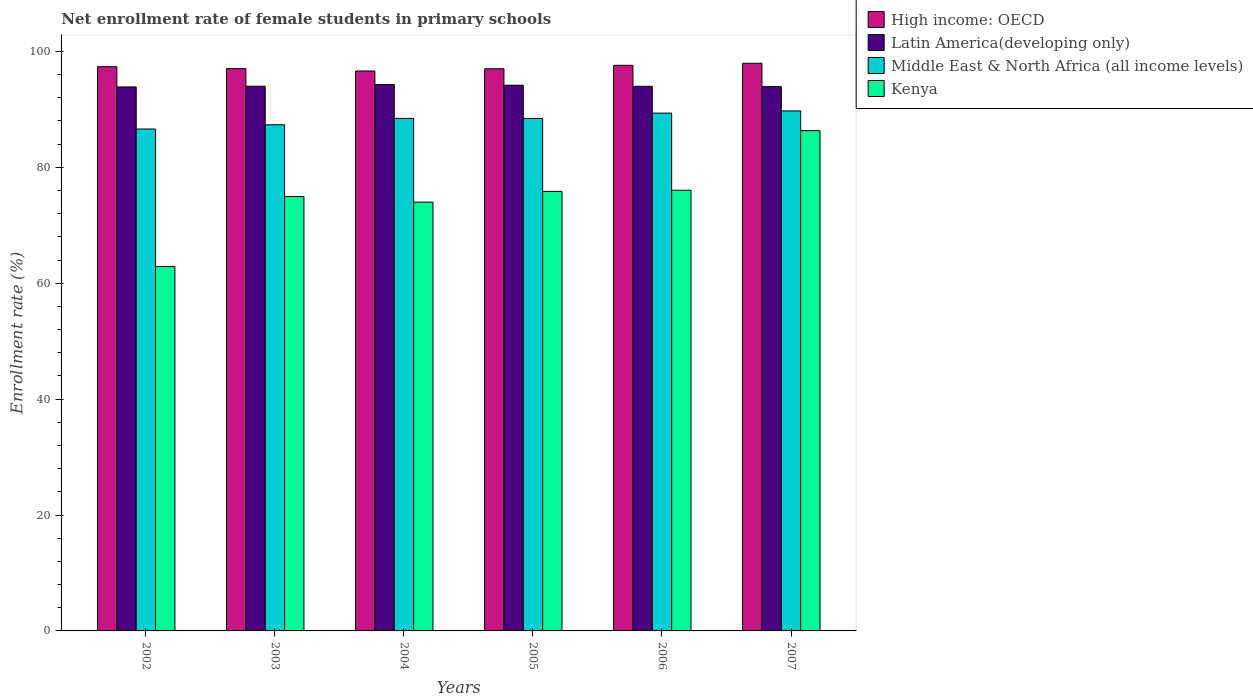How many groups of bars are there?
Make the answer very short. 6. Are the number of bars per tick equal to the number of legend labels?
Give a very brief answer. Yes. How many bars are there on the 2nd tick from the right?
Offer a terse response. 4. In how many cases, is the number of bars for a given year not equal to the number of legend labels?
Your response must be concise. 0. What is the net enrollment rate of female students in primary schools in High income: OECD in 2002?
Your answer should be compact. 97.37. Across all years, what is the maximum net enrollment rate of female students in primary schools in Latin America(developing only)?
Your answer should be very brief. 94.3. Across all years, what is the minimum net enrollment rate of female students in primary schools in Middle East & North Africa (all income levels)?
Keep it short and to the point. 86.61. In which year was the net enrollment rate of female students in primary schools in Kenya maximum?
Offer a very short reply. 2007. In which year was the net enrollment rate of female students in primary schools in Middle East & North Africa (all income levels) minimum?
Keep it short and to the point. 2002. What is the total net enrollment rate of female students in primary schools in Kenya in the graph?
Offer a terse response. 450.08. What is the difference between the net enrollment rate of female students in primary schools in Latin America(developing only) in 2004 and that in 2005?
Keep it short and to the point. 0.13. What is the difference between the net enrollment rate of female students in primary schools in High income: OECD in 2007 and the net enrollment rate of female students in primary schools in Middle East & North Africa (all income levels) in 2002?
Make the answer very short. 11.35. What is the average net enrollment rate of female students in primary schools in High income: OECD per year?
Offer a terse response. 97.27. In the year 2005, what is the difference between the net enrollment rate of female students in primary schools in Middle East & North Africa (all income levels) and net enrollment rate of female students in primary schools in High income: OECD?
Make the answer very short. -8.58. What is the ratio of the net enrollment rate of female students in primary schools in High income: OECD in 2002 to that in 2004?
Your response must be concise. 1.01. Is the net enrollment rate of female students in primary schools in High income: OECD in 2002 less than that in 2005?
Keep it short and to the point. No. Is the difference between the net enrollment rate of female students in primary schools in Middle East & North Africa (all income levels) in 2002 and 2005 greater than the difference between the net enrollment rate of female students in primary schools in High income: OECD in 2002 and 2005?
Provide a succinct answer. No. What is the difference between the highest and the second highest net enrollment rate of female students in primary schools in High income: OECD?
Provide a short and direct response. 0.35. What is the difference between the highest and the lowest net enrollment rate of female students in primary schools in Kenya?
Your answer should be very brief. 23.45. Is the sum of the net enrollment rate of female students in primary schools in Latin America(developing only) in 2005 and 2007 greater than the maximum net enrollment rate of female students in primary schools in Kenya across all years?
Provide a short and direct response. Yes. Is it the case that in every year, the sum of the net enrollment rate of female students in primary schools in Middle East & North Africa (all income levels) and net enrollment rate of female students in primary schools in Latin America(developing only) is greater than the sum of net enrollment rate of female students in primary schools in Kenya and net enrollment rate of female students in primary schools in High income: OECD?
Keep it short and to the point. No. What does the 2nd bar from the left in 2006 represents?
Your response must be concise. Latin America(developing only). What does the 3rd bar from the right in 2004 represents?
Offer a terse response. Latin America(developing only). Is it the case that in every year, the sum of the net enrollment rate of female students in primary schools in Latin America(developing only) and net enrollment rate of female students in primary schools in Middle East & North Africa (all income levels) is greater than the net enrollment rate of female students in primary schools in Kenya?
Provide a succinct answer. Yes. Are all the bars in the graph horizontal?
Provide a short and direct response. No. How many years are there in the graph?
Your answer should be very brief. 6. What is the difference between two consecutive major ticks on the Y-axis?
Give a very brief answer. 20. Are the values on the major ticks of Y-axis written in scientific E-notation?
Keep it short and to the point. No. Does the graph contain any zero values?
Your response must be concise. No. Does the graph contain grids?
Your answer should be very brief. No. Where does the legend appear in the graph?
Ensure brevity in your answer.  Top right. How many legend labels are there?
Give a very brief answer. 4. How are the legend labels stacked?
Offer a terse response. Vertical. What is the title of the graph?
Your answer should be compact. Net enrollment rate of female students in primary schools. Does "St. Kitts and Nevis" appear as one of the legend labels in the graph?
Offer a very short reply. No. What is the label or title of the X-axis?
Provide a short and direct response. Years. What is the label or title of the Y-axis?
Your answer should be compact. Enrollment rate (%). What is the Enrollment rate (%) in High income: OECD in 2002?
Offer a terse response. 97.37. What is the Enrollment rate (%) in Latin America(developing only) in 2002?
Provide a short and direct response. 93.88. What is the Enrollment rate (%) in Middle East & North Africa (all income levels) in 2002?
Provide a succinct answer. 86.61. What is the Enrollment rate (%) in Kenya in 2002?
Ensure brevity in your answer.  62.89. What is the Enrollment rate (%) in High income: OECD in 2003?
Ensure brevity in your answer.  97.03. What is the Enrollment rate (%) in Latin America(developing only) in 2003?
Provide a short and direct response. 94. What is the Enrollment rate (%) of Middle East & North Africa (all income levels) in 2003?
Your response must be concise. 87.35. What is the Enrollment rate (%) in Kenya in 2003?
Ensure brevity in your answer.  74.96. What is the Enrollment rate (%) in High income: OECD in 2004?
Give a very brief answer. 96.63. What is the Enrollment rate (%) in Latin America(developing only) in 2004?
Provide a short and direct response. 94.3. What is the Enrollment rate (%) in Middle East & North Africa (all income levels) in 2004?
Provide a succinct answer. 88.44. What is the Enrollment rate (%) in Kenya in 2004?
Provide a short and direct response. 73.99. What is the Enrollment rate (%) in High income: OECD in 2005?
Make the answer very short. 97.01. What is the Enrollment rate (%) of Latin America(developing only) in 2005?
Make the answer very short. 94.17. What is the Enrollment rate (%) of Middle East & North Africa (all income levels) in 2005?
Your answer should be very brief. 88.43. What is the Enrollment rate (%) in Kenya in 2005?
Provide a succinct answer. 75.85. What is the Enrollment rate (%) in High income: OECD in 2006?
Offer a very short reply. 97.61. What is the Enrollment rate (%) in Latin America(developing only) in 2006?
Make the answer very short. 93.98. What is the Enrollment rate (%) in Middle East & North Africa (all income levels) in 2006?
Your answer should be compact. 89.35. What is the Enrollment rate (%) of Kenya in 2006?
Make the answer very short. 76.05. What is the Enrollment rate (%) of High income: OECD in 2007?
Your answer should be very brief. 97.96. What is the Enrollment rate (%) in Latin America(developing only) in 2007?
Provide a succinct answer. 93.93. What is the Enrollment rate (%) of Middle East & North Africa (all income levels) in 2007?
Ensure brevity in your answer.  89.74. What is the Enrollment rate (%) in Kenya in 2007?
Keep it short and to the point. 86.34. Across all years, what is the maximum Enrollment rate (%) of High income: OECD?
Your answer should be compact. 97.96. Across all years, what is the maximum Enrollment rate (%) of Latin America(developing only)?
Your response must be concise. 94.3. Across all years, what is the maximum Enrollment rate (%) of Middle East & North Africa (all income levels)?
Make the answer very short. 89.74. Across all years, what is the maximum Enrollment rate (%) of Kenya?
Your answer should be very brief. 86.34. Across all years, what is the minimum Enrollment rate (%) of High income: OECD?
Provide a succinct answer. 96.63. Across all years, what is the minimum Enrollment rate (%) in Latin America(developing only)?
Provide a short and direct response. 93.88. Across all years, what is the minimum Enrollment rate (%) in Middle East & North Africa (all income levels)?
Your answer should be very brief. 86.61. Across all years, what is the minimum Enrollment rate (%) of Kenya?
Provide a succinct answer. 62.89. What is the total Enrollment rate (%) of High income: OECD in the graph?
Provide a short and direct response. 583.6. What is the total Enrollment rate (%) of Latin America(developing only) in the graph?
Make the answer very short. 564.26. What is the total Enrollment rate (%) in Middle East & North Africa (all income levels) in the graph?
Ensure brevity in your answer.  529.92. What is the total Enrollment rate (%) of Kenya in the graph?
Your response must be concise. 450.08. What is the difference between the Enrollment rate (%) in High income: OECD in 2002 and that in 2003?
Your answer should be very brief. 0.34. What is the difference between the Enrollment rate (%) in Latin America(developing only) in 2002 and that in 2003?
Give a very brief answer. -0.12. What is the difference between the Enrollment rate (%) of Middle East & North Africa (all income levels) in 2002 and that in 2003?
Provide a short and direct response. -0.74. What is the difference between the Enrollment rate (%) in Kenya in 2002 and that in 2003?
Make the answer very short. -12.07. What is the difference between the Enrollment rate (%) in High income: OECD in 2002 and that in 2004?
Offer a terse response. 0.74. What is the difference between the Enrollment rate (%) of Latin America(developing only) in 2002 and that in 2004?
Give a very brief answer. -0.42. What is the difference between the Enrollment rate (%) of Middle East & North Africa (all income levels) in 2002 and that in 2004?
Offer a terse response. -1.84. What is the difference between the Enrollment rate (%) of Kenya in 2002 and that in 2004?
Ensure brevity in your answer.  -11.1. What is the difference between the Enrollment rate (%) in High income: OECD in 2002 and that in 2005?
Keep it short and to the point. 0.36. What is the difference between the Enrollment rate (%) of Latin America(developing only) in 2002 and that in 2005?
Your response must be concise. -0.29. What is the difference between the Enrollment rate (%) in Middle East & North Africa (all income levels) in 2002 and that in 2005?
Offer a terse response. -1.82. What is the difference between the Enrollment rate (%) of Kenya in 2002 and that in 2005?
Ensure brevity in your answer.  -12.95. What is the difference between the Enrollment rate (%) of High income: OECD in 2002 and that in 2006?
Keep it short and to the point. -0.24. What is the difference between the Enrollment rate (%) in Latin America(developing only) in 2002 and that in 2006?
Keep it short and to the point. -0.1. What is the difference between the Enrollment rate (%) in Middle East & North Africa (all income levels) in 2002 and that in 2006?
Offer a terse response. -2.74. What is the difference between the Enrollment rate (%) in Kenya in 2002 and that in 2006?
Your answer should be compact. -13.16. What is the difference between the Enrollment rate (%) of High income: OECD in 2002 and that in 2007?
Keep it short and to the point. -0.59. What is the difference between the Enrollment rate (%) in Latin America(developing only) in 2002 and that in 2007?
Provide a succinct answer. -0.05. What is the difference between the Enrollment rate (%) in Middle East & North Africa (all income levels) in 2002 and that in 2007?
Provide a short and direct response. -3.13. What is the difference between the Enrollment rate (%) of Kenya in 2002 and that in 2007?
Offer a terse response. -23.45. What is the difference between the Enrollment rate (%) in High income: OECD in 2003 and that in 2004?
Make the answer very short. 0.4. What is the difference between the Enrollment rate (%) in Latin America(developing only) in 2003 and that in 2004?
Offer a terse response. -0.3. What is the difference between the Enrollment rate (%) in Middle East & North Africa (all income levels) in 2003 and that in 2004?
Provide a short and direct response. -1.1. What is the difference between the Enrollment rate (%) in Kenya in 2003 and that in 2004?
Provide a succinct answer. 0.97. What is the difference between the Enrollment rate (%) in High income: OECD in 2003 and that in 2005?
Make the answer very short. 0.02. What is the difference between the Enrollment rate (%) of Latin America(developing only) in 2003 and that in 2005?
Your answer should be very brief. -0.17. What is the difference between the Enrollment rate (%) of Middle East & North Africa (all income levels) in 2003 and that in 2005?
Your answer should be very brief. -1.08. What is the difference between the Enrollment rate (%) of Kenya in 2003 and that in 2005?
Your answer should be very brief. -0.89. What is the difference between the Enrollment rate (%) in High income: OECD in 2003 and that in 2006?
Offer a very short reply. -0.58. What is the difference between the Enrollment rate (%) in Latin America(developing only) in 2003 and that in 2006?
Keep it short and to the point. 0.02. What is the difference between the Enrollment rate (%) in Middle East & North Africa (all income levels) in 2003 and that in 2006?
Provide a short and direct response. -2.01. What is the difference between the Enrollment rate (%) in Kenya in 2003 and that in 2006?
Your response must be concise. -1.09. What is the difference between the Enrollment rate (%) of High income: OECD in 2003 and that in 2007?
Give a very brief answer. -0.93. What is the difference between the Enrollment rate (%) of Latin America(developing only) in 2003 and that in 2007?
Give a very brief answer. 0.07. What is the difference between the Enrollment rate (%) in Middle East & North Africa (all income levels) in 2003 and that in 2007?
Provide a short and direct response. -2.39. What is the difference between the Enrollment rate (%) of Kenya in 2003 and that in 2007?
Your answer should be very brief. -11.38. What is the difference between the Enrollment rate (%) in High income: OECD in 2004 and that in 2005?
Give a very brief answer. -0.38. What is the difference between the Enrollment rate (%) in Latin America(developing only) in 2004 and that in 2005?
Provide a succinct answer. 0.13. What is the difference between the Enrollment rate (%) of Middle East & North Africa (all income levels) in 2004 and that in 2005?
Ensure brevity in your answer.  0.01. What is the difference between the Enrollment rate (%) of Kenya in 2004 and that in 2005?
Provide a succinct answer. -1.85. What is the difference between the Enrollment rate (%) in High income: OECD in 2004 and that in 2006?
Your response must be concise. -0.98. What is the difference between the Enrollment rate (%) of Latin America(developing only) in 2004 and that in 2006?
Ensure brevity in your answer.  0.32. What is the difference between the Enrollment rate (%) of Middle East & North Africa (all income levels) in 2004 and that in 2006?
Your response must be concise. -0.91. What is the difference between the Enrollment rate (%) of Kenya in 2004 and that in 2006?
Give a very brief answer. -2.06. What is the difference between the Enrollment rate (%) in High income: OECD in 2004 and that in 2007?
Your response must be concise. -1.33. What is the difference between the Enrollment rate (%) of Latin America(developing only) in 2004 and that in 2007?
Your response must be concise. 0.37. What is the difference between the Enrollment rate (%) in Middle East & North Africa (all income levels) in 2004 and that in 2007?
Offer a very short reply. -1.29. What is the difference between the Enrollment rate (%) of Kenya in 2004 and that in 2007?
Ensure brevity in your answer.  -12.35. What is the difference between the Enrollment rate (%) in High income: OECD in 2005 and that in 2006?
Your answer should be compact. -0.6. What is the difference between the Enrollment rate (%) of Latin America(developing only) in 2005 and that in 2006?
Give a very brief answer. 0.19. What is the difference between the Enrollment rate (%) of Middle East & North Africa (all income levels) in 2005 and that in 2006?
Keep it short and to the point. -0.92. What is the difference between the Enrollment rate (%) of Kenya in 2005 and that in 2006?
Keep it short and to the point. -0.21. What is the difference between the Enrollment rate (%) in High income: OECD in 2005 and that in 2007?
Your answer should be very brief. -0.95. What is the difference between the Enrollment rate (%) in Latin America(developing only) in 2005 and that in 2007?
Provide a short and direct response. 0.24. What is the difference between the Enrollment rate (%) of Middle East & North Africa (all income levels) in 2005 and that in 2007?
Your answer should be compact. -1.31. What is the difference between the Enrollment rate (%) in Kenya in 2005 and that in 2007?
Your answer should be compact. -10.49. What is the difference between the Enrollment rate (%) in High income: OECD in 2006 and that in 2007?
Your answer should be compact. -0.35. What is the difference between the Enrollment rate (%) of Latin America(developing only) in 2006 and that in 2007?
Keep it short and to the point. 0.05. What is the difference between the Enrollment rate (%) of Middle East & North Africa (all income levels) in 2006 and that in 2007?
Give a very brief answer. -0.38. What is the difference between the Enrollment rate (%) of Kenya in 2006 and that in 2007?
Provide a short and direct response. -10.29. What is the difference between the Enrollment rate (%) of High income: OECD in 2002 and the Enrollment rate (%) of Latin America(developing only) in 2003?
Offer a very short reply. 3.37. What is the difference between the Enrollment rate (%) of High income: OECD in 2002 and the Enrollment rate (%) of Middle East & North Africa (all income levels) in 2003?
Give a very brief answer. 10.02. What is the difference between the Enrollment rate (%) in High income: OECD in 2002 and the Enrollment rate (%) in Kenya in 2003?
Your response must be concise. 22.41. What is the difference between the Enrollment rate (%) in Latin America(developing only) in 2002 and the Enrollment rate (%) in Middle East & North Africa (all income levels) in 2003?
Ensure brevity in your answer.  6.53. What is the difference between the Enrollment rate (%) of Latin America(developing only) in 2002 and the Enrollment rate (%) of Kenya in 2003?
Provide a short and direct response. 18.92. What is the difference between the Enrollment rate (%) of Middle East & North Africa (all income levels) in 2002 and the Enrollment rate (%) of Kenya in 2003?
Give a very brief answer. 11.65. What is the difference between the Enrollment rate (%) in High income: OECD in 2002 and the Enrollment rate (%) in Latin America(developing only) in 2004?
Your answer should be very brief. 3.07. What is the difference between the Enrollment rate (%) in High income: OECD in 2002 and the Enrollment rate (%) in Middle East & North Africa (all income levels) in 2004?
Offer a terse response. 8.92. What is the difference between the Enrollment rate (%) in High income: OECD in 2002 and the Enrollment rate (%) in Kenya in 2004?
Keep it short and to the point. 23.38. What is the difference between the Enrollment rate (%) in Latin America(developing only) in 2002 and the Enrollment rate (%) in Middle East & North Africa (all income levels) in 2004?
Provide a short and direct response. 5.43. What is the difference between the Enrollment rate (%) of Latin America(developing only) in 2002 and the Enrollment rate (%) of Kenya in 2004?
Give a very brief answer. 19.89. What is the difference between the Enrollment rate (%) in Middle East & North Africa (all income levels) in 2002 and the Enrollment rate (%) in Kenya in 2004?
Your answer should be very brief. 12.62. What is the difference between the Enrollment rate (%) in High income: OECD in 2002 and the Enrollment rate (%) in Latin America(developing only) in 2005?
Your answer should be compact. 3.2. What is the difference between the Enrollment rate (%) of High income: OECD in 2002 and the Enrollment rate (%) of Middle East & North Africa (all income levels) in 2005?
Ensure brevity in your answer.  8.94. What is the difference between the Enrollment rate (%) of High income: OECD in 2002 and the Enrollment rate (%) of Kenya in 2005?
Keep it short and to the point. 21.52. What is the difference between the Enrollment rate (%) in Latin America(developing only) in 2002 and the Enrollment rate (%) in Middle East & North Africa (all income levels) in 2005?
Your response must be concise. 5.45. What is the difference between the Enrollment rate (%) in Latin America(developing only) in 2002 and the Enrollment rate (%) in Kenya in 2005?
Offer a terse response. 18.03. What is the difference between the Enrollment rate (%) in Middle East & North Africa (all income levels) in 2002 and the Enrollment rate (%) in Kenya in 2005?
Make the answer very short. 10.76. What is the difference between the Enrollment rate (%) of High income: OECD in 2002 and the Enrollment rate (%) of Latin America(developing only) in 2006?
Make the answer very short. 3.39. What is the difference between the Enrollment rate (%) of High income: OECD in 2002 and the Enrollment rate (%) of Middle East & North Africa (all income levels) in 2006?
Give a very brief answer. 8.02. What is the difference between the Enrollment rate (%) of High income: OECD in 2002 and the Enrollment rate (%) of Kenya in 2006?
Offer a very short reply. 21.32. What is the difference between the Enrollment rate (%) in Latin America(developing only) in 2002 and the Enrollment rate (%) in Middle East & North Africa (all income levels) in 2006?
Provide a succinct answer. 4.52. What is the difference between the Enrollment rate (%) in Latin America(developing only) in 2002 and the Enrollment rate (%) in Kenya in 2006?
Your answer should be very brief. 17.82. What is the difference between the Enrollment rate (%) in Middle East & North Africa (all income levels) in 2002 and the Enrollment rate (%) in Kenya in 2006?
Provide a succinct answer. 10.56. What is the difference between the Enrollment rate (%) in High income: OECD in 2002 and the Enrollment rate (%) in Latin America(developing only) in 2007?
Your answer should be very brief. 3.44. What is the difference between the Enrollment rate (%) in High income: OECD in 2002 and the Enrollment rate (%) in Middle East & North Africa (all income levels) in 2007?
Offer a very short reply. 7.63. What is the difference between the Enrollment rate (%) of High income: OECD in 2002 and the Enrollment rate (%) of Kenya in 2007?
Provide a succinct answer. 11.03. What is the difference between the Enrollment rate (%) of Latin America(developing only) in 2002 and the Enrollment rate (%) of Middle East & North Africa (all income levels) in 2007?
Your response must be concise. 4.14. What is the difference between the Enrollment rate (%) of Latin America(developing only) in 2002 and the Enrollment rate (%) of Kenya in 2007?
Make the answer very short. 7.54. What is the difference between the Enrollment rate (%) of Middle East & North Africa (all income levels) in 2002 and the Enrollment rate (%) of Kenya in 2007?
Provide a succinct answer. 0.27. What is the difference between the Enrollment rate (%) of High income: OECD in 2003 and the Enrollment rate (%) of Latin America(developing only) in 2004?
Your response must be concise. 2.73. What is the difference between the Enrollment rate (%) in High income: OECD in 2003 and the Enrollment rate (%) in Middle East & North Africa (all income levels) in 2004?
Your response must be concise. 8.58. What is the difference between the Enrollment rate (%) of High income: OECD in 2003 and the Enrollment rate (%) of Kenya in 2004?
Give a very brief answer. 23.04. What is the difference between the Enrollment rate (%) of Latin America(developing only) in 2003 and the Enrollment rate (%) of Middle East & North Africa (all income levels) in 2004?
Keep it short and to the point. 5.55. What is the difference between the Enrollment rate (%) in Latin America(developing only) in 2003 and the Enrollment rate (%) in Kenya in 2004?
Your response must be concise. 20.01. What is the difference between the Enrollment rate (%) of Middle East & North Africa (all income levels) in 2003 and the Enrollment rate (%) of Kenya in 2004?
Ensure brevity in your answer.  13.36. What is the difference between the Enrollment rate (%) of High income: OECD in 2003 and the Enrollment rate (%) of Latin America(developing only) in 2005?
Your response must be concise. 2.86. What is the difference between the Enrollment rate (%) in High income: OECD in 2003 and the Enrollment rate (%) in Middle East & North Africa (all income levels) in 2005?
Keep it short and to the point. 8.6. What is the difference between the Enrollment rate (%) of High income: OECD in 2003 and the Enrollment rate (%) of Kenya in 2005?
Offer a terse response. 21.18. What is the difference between the Enrollment rate (%) in Latin America(developing only) in 2003 and the Enrollment rate (%) in Middle East & North Africa (all income levels) in 2005?
Offer a terse response. 5.57. What is the difference between the Enrollment rate (%) in Latin America(developing only) in 2003 and the Enrollment rate (%) in Kenya in 2005?
Provide a succinct answer. 18.15. What is the difference between the Enrollment rate (%) of Middle East & North Africa (all income levels) in 2003 and the Enrollment rate (%) of Kenya in 2005?
Provide a succinct answer. 11.5. What is the difference between the Enrollment rate (%) of High income: OECD in 2003 and the Enrollment rate (%) of Latin America(developing only) in 2006?
Make the answer very short. 3.05. What is the difference between the Enrollment rate (%) in High income: OECD in 2003 and the Enrollment rate (%) in Middle East & North Africa (all income levels) in 2006?
Keep it short and to the point. 7.68. What is the difference between the Enrollment rate (%) of High income: OECD in 2003 and the Enrollment rate (%) of Kenya in 2006?
Ensure brevity in your answer.  20.98. What is the difference between the Enrollment rate (%) in Latin America(developing only) in 2003 and the Enrollment rate (%) in Middle East & North Africa (all income levels) in 2006?
Offer a terse response. 4.65. What is the difference between the Enrollment rate (%) in Latin America(developing only) in 2003 and the Enrollment rate (%) in Kenya in 2006?
Offer a terse response. 17.95. What is the difference between the Enrollment rate (%) in Middle East & North Africa (all income levels) in 2003 and the Enrollment rate (%) in Kenya in 2006?
Give a very brief answer. 11.29. What is the difference between the Enrollment rate (%) of High income: OECD in 2003 and the Enrollment rate (%) of Latin America(developing only) in 2007?
Your response must be concise. 3.1. What is the difference between the Enrollment rate (%) in High income: OECD in 2003 and the Enrollment rate (%) in Middle East & North Africa (all income levels) in 2007?
Keep it short and to the point. 7.29. What is the difference between the Enrollment rate (%) in High income: OECD in 2003 and the Enrollment rate (%) in Kenya in 2007?
Provide a short and direct response. 10.69. What is the difference between the Enrollment rate (%) of Latin America(developing only) in 2003 and the Enrollment rate (%) of Middle East & North Africa (all income levels) in 2007?
Make the answer very short. 4.26. What is the difference between the Enrollment rate (%) in Latin America(developing only) in 2003 and the Enrollment rate (%) in Kenya in 2007?
Make the answer very short. 7.66. What is the difference between the Enrollment rate (%) in High income: OECD in 2004 and the Enrollment rate (%) in Latin America(developing only) in 2005?
Ensure brevity in your answer.  2.46. What is the difference between the Enrollment rate (%) in High income: OECD in 2004 and the Enrollment rate (%) in Middle East & North Africa (all income levels) in 2005?
Ensure brevity in your answer.  8.2. What is the difference between the Enrollment rate (%) of High income: OECD in 2004 and the Enrollment rate (%) of Kenya in 2005?
Offer a terse response. 20.78. What is the difference between the Enrollment rate (%) in Latin America(developing only) in 2004 and the Enrollment rate (%) in Middle East & North Africa (all income levels) in 2005?
Keep it short and to the point. 5.87. What is the difference between the Enrollment rate (%) in Latin America(developing only) in 2004 and the Enrollment rate (%) in Kenya in 2005?
Your response must be concise. 18.45. What is the difference between the Enrollment rate (%) in Middle East & North Africa (all income levels) in 2004 and the Enrollment rate (%) in Kenya in 2005?
Make the answer very short. 12.6. What is the difference between the Enrollment rate (%) of High income: OECD in 2004 and the Enrollment rate (%) of Latin America(developing only) in 2006?
Your answer should be compact. 2.65. What is the difference between the Enrollment rate (%) in High income: OECD in 2004 and the Enrollment rate (%) in Middle East & North Africa (all income levels) in 2006?
Provide a succinct answer. 7.27. What is the difference between the Enrollment rate (%) in High income: OECD in 2004 and the Enrollment rate (%) in Kenya in 2006?
Offer a very short reply. 20.57. What is the difference between the Enrollment rate (%) in Latin America(developing only) in 2004 and the Enrollment rate (%) in Middle East & North Africa (all income levels) in 2006?
Give a very brief answer. 4.94. What is the difference between the Enrollment rate (%) of Latin America(developing only) in 2004 and the Enrollment rate (%) of Kenya in 2006?
Keep it short and to the point. 18.25. What is the difference between the Enrollment rate (%) in Middle East & North Africa (all income levels) in 2004 and the Enrollment rate (%) in Kenya in 2006?
Give a very brief answer. 12.39. What is the difference between the Enrollment rate (%) in High income: OECD in 2004 and the Enrollment rate (%) in Latin America(developing only) in 2007?
Provide a succinct answer. 2.7. What is the difference between the Enrollment rate (%) of High income: OECD in 2004 and the Enrollment rate (%) of Middle East & North Africa (all income levels) in 2007?
Your answer should be very brief. 6.89. What is the difference between the Enrollment rate (%) of High income: OECD in 2004 and the Enrollment rate (%) of Kenya in 2007?
Ensure brevity in your answer.  10.29. What is the difference between the Enrollment rate (%) in Latin America(developing only) in 2004 and the Enrollment rate (%) in Middle East & North Africa (all income levels) in 2007?
Provide a short and direct response. 4.56. What is the difference between the Enrollment rate (%) in Latin America(developing only) in 2004 and the Enrollment rate (%) in Kenya in 2007?
Ensure brevity in your answer.  7.96. What is the difference between the Enrollment rate (%) in Middle East & North Africa (all income levels) in 2004 and the Enrollment rate (%) in Kenya in 2007?
Provide a succinct answer. 2.11. What is the difference between the Enrollment rate (%) of High income: OECD in 2005 and the Enrollment rate (%) of Latin America(developing only) in 2006?
Provide a succinct answer. 3.03. What is the difference between the Enrollment rate (%) in High income: OECD in 2005 and the Enrollment rate (%) in Middle East & North Africa (all income levels) in 2006?
Provide a short and direct response. 7.66. What is the difference between the Enrollment rate (%) of High income: OECD in 2005 and the Enrollment rate (%) of Kenya in 2006?
Keep it short and to the point. 20.96. What is the difference between the Enrollment rate (%) in Latin America(developing only) in 2005 and the Enrollment rate (%) in Middle East & North Africa (all income levels) in 2006?
Offer a terse response. 4.81. What is the difference between the Enrollment rate (%) of Latin America(developing only) in 2005 and the Enrollment rate (%) of Kenya in 2006?
Keep it short and to the point. 18.12. What is the difference between the Enrollment rate (%) in Middle East & North Africa (all income levels) in 2005 and the Enrollment rate (%) in Kenya in 2006?
Your answer should be compact. 12.38. What is the difference between the Enrollment rate (%) of High income: OECD in 2005 and the Enrollment rate (%) of Latin America(developing only) in 2007?
Give a very brief answer. 3.08. What is the difference between the Enrollment rate (%) in High income: OECD in 2005 and the Enrollment rate (%) in Middle East & North Africa (all income levels) in 2007?
Offer a very short reply. 7.28. What is the difference between the Enrollment rate (%) in High income: OECD in 2005 and the Enrollment rate (%) in Kenya in 2007?
Your answer should be compact. 10.67. What is the difference between the Enrollment rate (%) of Latin America(developing only) in 2005 and the Enrollment rate (%) of Middle East & North Africa (all income levels) in 2007?
Provide a short and direct response. 4.43. What is the difference between the Enrollment rate (%) of Latin America(developing only) in 2005 and the Enrollment rate (%) of Kenya in 2007?
Your answer should be compact. 7.83. What is the difference between the Enrollment rate (%) in Middle East & North Africa (all income levels) in 2005 and the Enrollment rate (%) in Kenya in 2007?
Give a very brief answer. 2.09. What is the difference between the Enrollment rate (%) of High income: OECD in 2006 and the Enrollment rate (%) of Latin America(developing only) in 2007?
Your answer should be compact. 3.68. What is the difference between the Enrollment rate (%) of High income: OECD in 2006 and the Enrollment rate (%) of Middle East & North Africa (all income levels) in 2007?
Your response must be concise. 7.87. What is the difference between the Enrollment rate (%) in High income: OECD in 2006 and the Enrollment rate (%) in Kenya in 2007?
Provide a succinct answer. 11.27. What is the difference between the Enrollment rate (%) in Latin America(developing only) in 2006 and the Enrollment rate (%) in Middle East & North Africa (all income levels) in 2007?
Make the answer very short. 4.25. What is the difference between the Enrollment rate (%) of Latin America(developing only) in 2006 and the Enrollment rate (%) of Kenya in 2007?
Your response must be concise. 7.64. What is the difference between the Enrollment rate (%) of Middle East & North Africa (all income levels) in 2006 and the Enrollment rate (%) of Kenya in 2007?
Offer a terse response. 3.01. What is the average Enrollment rate (%) in High income: OECD per year?
Offer a very short reply. 97.27. What is the average Enrollment rate (%) in Latin America(developing only) per year?
Ensure brevity in your answer.  94.04. What is the average Enrollment rate (%) of Middle East & North Africa (all income levels) per year?
Provide a short and direct response. 88.32. What is the average Enrollment rate (%) of Kenya per year?
Offer a terse response. 75.01. In the year 2002, what is the difference between the Enrollment rate (%) in High income: OECD and Enrollment rate (%) in Latin America(developing only)?
Your response must be concise. 3.49. In the year 2002, what is the difference between the Enrollment rate (%) of High income: OECD and Enrollment rate (%) of Middle East & North Africa (all income levels)?
Provide a short and direct response. 10.76. In the year 2002, what is the difference between the Enrollment rate (%) in High income: OECD and Enrollment rate (%) in Kenya?
Ensure brevity in your answer.  34.48. In the year 2002, what is the difference between the Enrollment rate (%) of Latin America(developing only) and Enrollment rate (%) of Middle East & North Africa (all income levels)?
Offer a terse response. 7.27. In the year 2002, what is the difference between the Enrollment rate (%) of Latin America(developing only) and Enrollment rate (%) of Kenya?
Your answer should be compact. 30.98. In the year 2002, what is the difference between the Enrollment rate (%) of Middle East & North Africa (all income levels) and Enrollment rate (%) of Kenya?
Provide a short and direct response. 23.72. In the year 2003, what is the difference between the Enrollment rate (%) of High income: OECD and Enrollment rate (%) of Latin America(developing only)?
Offer a terse response. 3.03. In the year 2003, what is the difference between the Enrollment rate (%) in High income: OECD and Enrollment rate (%) in Middle East & North Africa (all income levels)?
Your response must be concise. 9.68. In the year 2003, what is the difference between the Enrollment rate (%) of High income: OECD and Enrollment rate (%) of Kenya?
Provide a succinct answer. 22.07. In the year 2003, what is the difference between the Enrollment rate (%) in Latin America(developing only) and Enrollment rate (%) in Middle East & North Africa (all income levels)?
Provide a short and direct response. 6.65. In the year 2003, what is the difference between the Enrollment rate (%) in Latin America(developing only) and Enrollment rate (%) in Kenya?
Ensure brevity in your answer.  19.04. In the year 2003, what is the difference between the Enrollment rate (%) of Middle East & North Africa (all income levels) and Enrollment rate (%) of Kenya?
Ensure brevity in your answer.  12.39. In the year 2004, what is the difference between the Enrollment rate (%) of High income: OECD and Enrollment rate (%) of Latin America(developing only)?
Ensure brevity in your answer.  2.33. In the year 2004, what is the difference between the Enrollment rate (%) of High income: OECD and Enrollment rate (%) of Middle East & North Africa (all income levels)?
Provide a succinct answer. 8.18. In the year 2004, what is the difference between the Enrollment rate (%) in High income: OECD and Enrollment rate (%) in Kenya?
Keep it short and to the point. 22.64. In the year 2004, what is the difference between the Enrollment rate (%) in Latin America(developing only) and Enrollment rate (%) in Middle East & North Africa (all income levels)?
Ensure brevity in your answer.  5.85. In the year 2004, what is the difference between the Enrollment rate (%) in Latin America(developing only) and Enrollment rate (%) in Kenya?
Make the answer very short. 20.31. In the year 2004, what is the difference between the Enrollment rate (%) in Middle East & North Africa (all income levels) and Enrollment rate (%) in Kenya?
Your response must be concise. 14.45. In the year 2005, what is the difference between the Enrollment rate (%) of High income: OECD and Enrollment rate (%) of Latin America(developing only)?
Provide a short and direct response. 2.84. In the year 2005, what is the difference between the Enrollment rate (%) of High income: OECD and Enrollment rate (%) of Middle East & North Africa (all income levels)?
Your answer should be compact. 8.58. In the year 2005, what is the difference between the Enrollment rate (%) in High income: OECD and Enrollment rate (%) in Kenya?
Offer a terse response. 21.16. In the year 2005, what is the difference between the Enrollment rate (%) in Latin America(developing only) and Enrollment rate (%) in Middle East & North Africa (all income levels)?
Provide a succinct answer. 5.74. In the year 2005, what is the difference between the Enrollment rate (%) in Latin America(developing only) and Enrollment rate (%) in Kenya?
Give a very brief answer. 18.32. In the year 2005, what is the difference between the Enrollment rate (%) in Middle East & North Africa (all income levels) and Enrollment rate (%) in Kenya?
Your answer should be compact. 12.58. In the year 2006, what is the difference between the Enrollment rate (%) in High income: OECD and Enrollment rate (%) in Latin America(developing only)?
Make the answer very short. 3.63. In the year 2006, what is the difference between the Enrollment rate (%) of High income: OECD and Enrollment rate (%) of Middle East & North Africa (all income levels)?
Your response must be concise. 8.25. In the year 2006, what is the difference between the Enrollment rate (%) of High income: OECD and Enrollment rate (%) of Kenya?
Provide a succinct answer. 21.55. In the year 2006, what is the difference between the Enrollment rate (%) of Latin America(developing only) and Enrollment rate (%) of Middle East & North Africa (all income levels)?
Your response must be concise. 4.63. In the year 2006, what is the difference between the Enrollment rate (%) of Latin America(developing only) and Enrollment rate (%) of Kenya?
Keep it short and to the point. 17.93. In the year 2006, what is the difference between the Enrollment rate (%) of Middle East & North Africa (all income levels) and Enrollment rate (%) of Kenya?
Your answer should be compact. 13.3. In the year 2007, what is the difference between the Enrollment rate (%) in High income: OECD and Enrollment rate (%) in Latin America(developing only)?
Give a very brief answer. 4.03. In the year 2007, what is the difference between the Enrollment rate (%) of High income: OECD and Enrollment rate (%) of Middle East & North Africa (all income levels)?
Offer a terse response. 8.22. In the year 2007, what is the difference between the Enrollment rate (%) in High income: OECD and Enrollment rate (%) in Kenya?
Keep it short and to the point. 11.62. In the year 2007, what is the difference between the Enrollment rate (%) in Latin America(developing only) and Enrollment rate (%) in Middle East & North Africa (all income levels)?
Offer a very short reply. 4.2. In the year 2007, what is the difference between the Enrollment rate (%) in Latin America(developing only) and Enrollment rate (%) in Kenya?
Keep it short and to the point. 7.59. In the year 2007, what is the difference between the Enrollment rate (%) in Middle East & North Africa (all income levels) and Enrollment rate (%) in Kenya?
Offer a very short reply. 3.4. What is the ratio of the Enrollment rate (%) in High income: OECD in 2002 to that in 2003?
Offer a very short reply. 1. What is the ratio of the Enrollment rate (%) of Kenya in 2002 to that in 2003?
Your response must be concise. 0.84. What is the ratio of the Enrollment rate (%) in High income: OECD in 2002 to that in 2004?
Offer a terse response. 1.01. What is the ratio of the Enrollment rate (%) of Middle East & North Africa (all income levels) in 2002 to that in 2004?
Offer a very short reply. 0.98. What is the ratio of the Enrollment rate (%) in Latin America(developing only) in 2002 to that in 2005?
Your response must be concise. 1. What is the ratio of the Enrollment rate (%) of Middle East & North Africa (all income levels) in 2002 to that in 2005?
Make the answer very short. 0.98. What is the ratio of the Enrollment rate (%) of Kenya in 2002 to that in 2005?
Offer a terse response. 0.83. What is the ratio of the Enrollment rate (%) in Latin America(developing only) in 2002 to that in 2006?
Your response must be concise. 1. What is the ratio of the Enrollment rate (%) of Middle East & North Africa (all income levels) in 2002 to that in 2006?
Offer a very short reply. 0.97. What is the ratio of the Enrollment rate (%) of Kenya in 2002 to that in 2006?
Offer a terse response. 0.83. What is the ratio of the Enrollment rate (%) of High income: OECD in 2002 to that in 2007?
Provide a short and direct response. 0.99. What is the ratio of the Enrollment rate (%) of Middle East & North Africa (all income levels) in 2002 to that in 2007?
Give a very brief answer. 0.97. What is the ratio of the Enrollment rate (%) in Kenya in 2002 to that in 2007?
Keep it short and to the point. 0.73. What is the ratio of the Enrollment rate (%) in Latin America(developing only) in 2003 to that in 2004?
Offer a terse response. 1. What is the ratio of the Enrollment rate (%) of Middle East & North Africa (all income levels) in 2003 to that in 2004?
Provide a short and direct response. 0.99. What is the ratio of the Enrollment rate (%) in Kenya in 2003 to that in 2004?
Give a very brief answer. 1.01. What is the ratio of the Enrollment rate (%) of Kenya in 2003 to that in 2005?
Ensure brevity in your answer.  0.99. What is the ratio of the Enrollment rate (%) in Middle East & North Africa (all income levels) in 2003 to that in 2006?
Offer a very short reply. 0.98. What is the ratio of the Enrollment rate (%) in Kenya in 2003 to that in 2006?
Make the answer very short. 0.99. What is the ratio of the Enrollment rate (%) of Latin America(developing only) in 2003 to that in 2007?
Ensure brevity in your answer.  1. What is the ratio of the Enrollment rate (%) in Middle East & North Africa (all income levels) in 2003 to that in 2007?
Your answer should be very brief. 0.97. What is the ratio of the Enrollment rate (%) in Kenya in 2003 to that in 2007?
Your answer should be compact. 0.87. What is the ratio of the Enrollment rate (%) in High income: OECD in 2004 to that in 2005?
Make the answer very short. 1. What is the ratio of the Enrollment rate (%) of Kenya in 2004 to that in 2005?
Your response must be concise. 0.98. What is the ratio of the Enrollment rate (%) in Latin America(developing only) in 2004 to that in 2006?
Your response must be concise. 1. What is the ratio of the Enrollment rate (%) in Middle East & North Africa (all income levels) in 2004 to that in 2006?
Your answer should be very brief. 0.99. What is the ratio of the Enrollment rate (%) in Kenya in 2004 to that in 2006?
Keep it short and to the point. 0.97. What is the ratio of the Enrollment rate (%) of High income: OECD in 2004 to that in 2007?
Offer a very short reply. 0.99. What is the ratio of the Enrollment rate (%) of Middle East & North Africa (all income levels) in 2004 to that in 2007?
Make the answer very short. 0.99. What is the ratio of the Enrollment rate (%) of Kenya in 2004 to that in 2007?
Offer a very short reply. 0.86. What is the ratio of the Enrollment rate (%) of High income: OECD in 2005 to that in 2006?
Ensure brevity in your answer.  0.99. What is the ratio of the Enrollment rate (%) in Latin America(developing only) in 2005 to that in 2006?
Make the answer very short. 1. What is the ratio of the Enrollment rate (%) of Middle East & North Africa (all income levels) in 2005 to that in 2006?
Provide a succinct answer. 0.99. What is the ratio of the Enrollment rate (%) in High income: OECD in 2005 to that in 2007?
Offer a very short reply. 0.99. What is the ratio of the Enrollment rate (%) of Latin America(developing only) in 2005 to that in 2007?
Your answer should be compact. 1. What is the ratio of the Enrollment rate (%) in Middle East & North Africa (all income levels) in 2005 to that in 2007?
Give a very brief answer. 0.99. What is the ratio of the Enrollment rate (%) in Kenya in 2005 to that in 2007?
Keep it short and to the point. 0.88. What is the ratio of the Enrollment rate (%) of High income: OECD in 2006 to that in 2007?
Ensure brevity in your answer.  1. What is the ratio of the Enrollment rate (%) of Latin America(developing only) in 2006 to that in 2007?
Give a very brief answer. 1. What is the ratio of the Enrollment rate (%) in Middle East & North Africa (all income levels) in 2006 to that in 2007?
Your answer should be very brief. 1. What is the ratio of the Enrollment rate (%) of Kenya in 2006 to that in 2007?
Offer a terse response. 0.88. What is the difference between the highest and the second highest Enrollment rate (%) in High income: OECD?
Provide a succinct answer. 0.35. What is the difference between the highest and the second highest Enrollment rate (%) of Latin America(developing only)?
Ensure brevity in your answer.  0.13. What is the difference between the highest and the second highest Enrollment rate (%) of Middle East & North Africa (all income levels)?
Your answer should be compact. 0.38. What is the difference between the highest and the second highest Enrollment rate (%) of Kenya?
Give a very brief answer. 10.29. What is the difference between the highest and the lowest Enrollment rate (%) in High income: OECD?
Your answer should be compact. 1.33. What is the difference between the highest and the lowest Enrollment rate (%) of Latin America(developing only)?
Your answer should be very brief. 0.42. What is the difference between the highest and the lowest Enrollment rate (%) in Middle East & North Africa (all income levels)?
Offer a terse response. 3.13. What is the difference between the highest and the lowest Enrollment rate (%) of Kenya?
Provide a short and direct response. 23.45. 